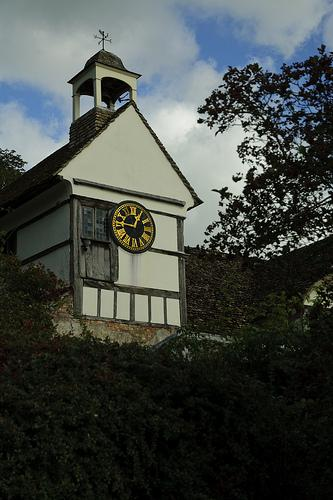Question: what color is the hands on the clock?
Choices:
A. Black.
B. Brown.
C. Green.
D. Gold.
Answer with the letter. Answer: D Question: how many animals are seen?
Choices:
A. One.
B. Two.
C. Zero.
D. Three.
Answer with the letter. Answer: C 